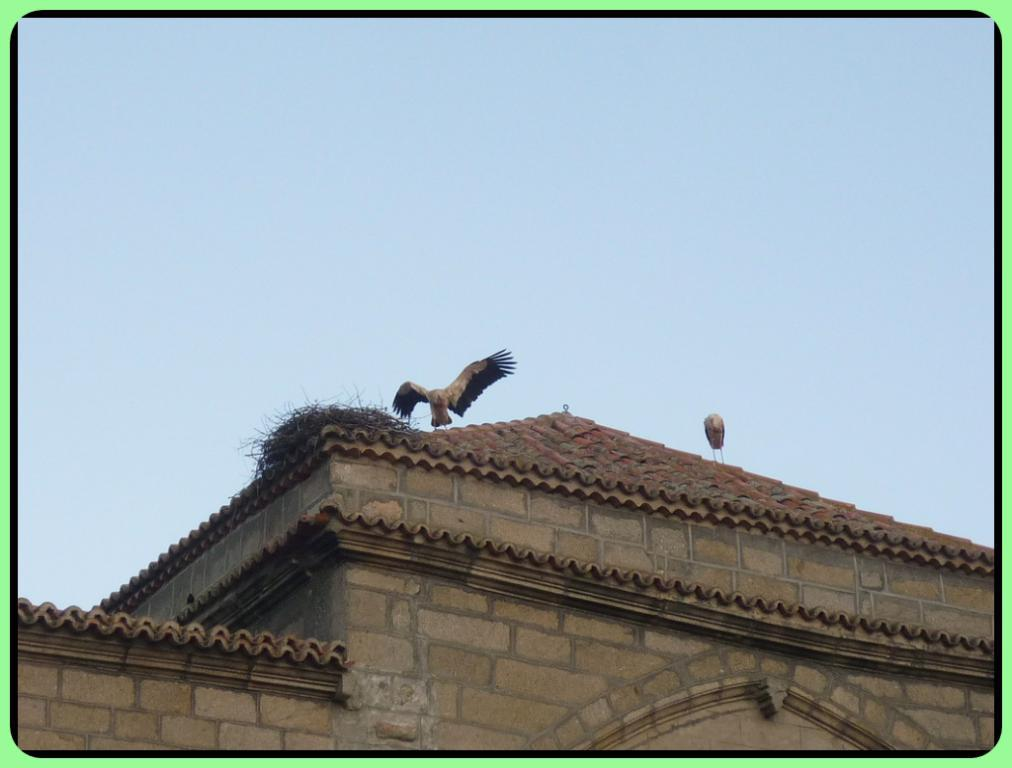What type of structure is present in the image? There is a building in the image. What other living creatures can be seen in the image? Birds are visible in the image. What part of the natural environment is visible in the image? The sky is visible at the top of the image. What type of magic does the uncle perform in the image? There is no uncle or magic present in the image. Can you see a cat in the image? There is no cat present in the image. 